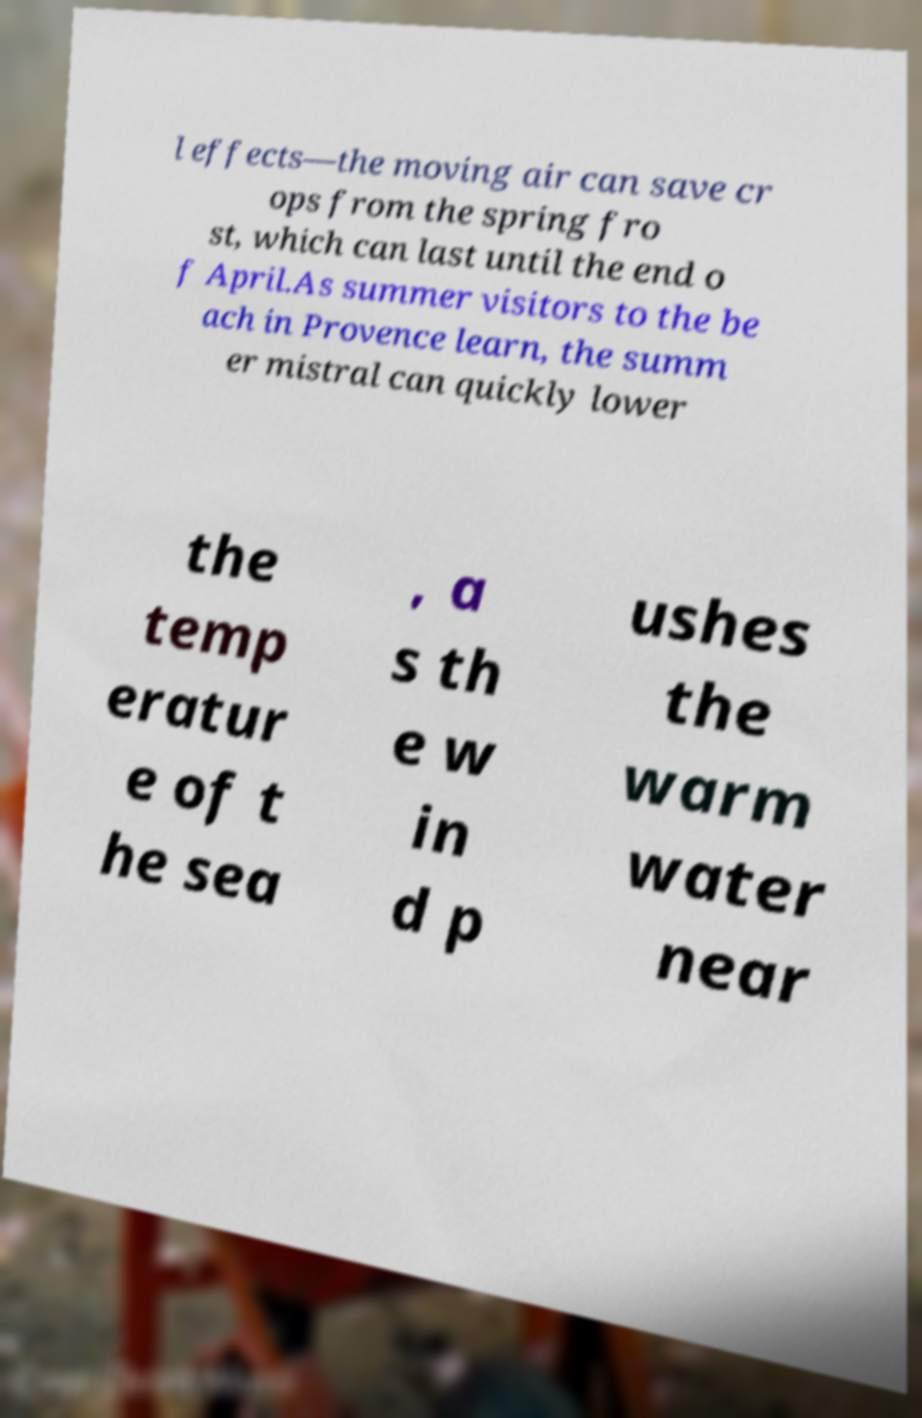Can you accurately transcribe the text from the provided image for me? l effects—the moving air can save cr ops from the spring fro st, which can last until the end o f April.As summer visitors to the be ach in Provence learn, the summ er mistral can quickly lower the temp eratur e of t he sea , a s th e w in d p ushes the warm water near 